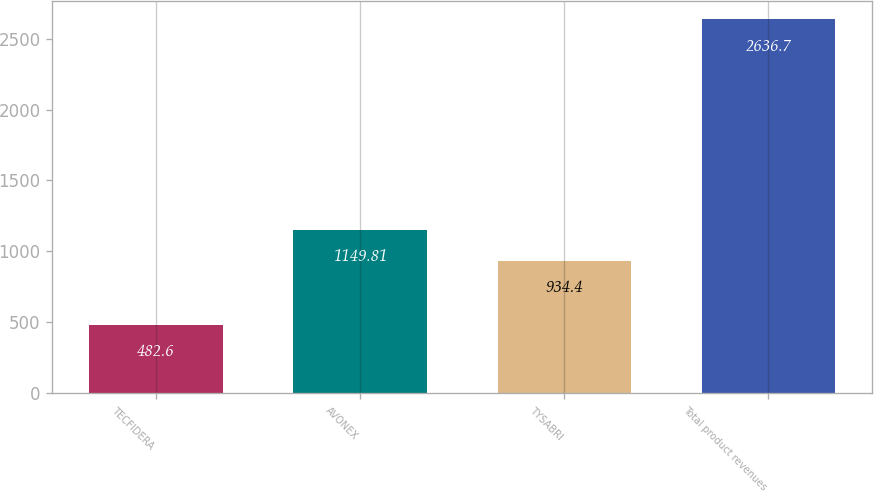Convert chart. <chart><loc_0><loc_0><loc_500><loc_500><bar_chart><fcel>TECFIDERA<fcel>AVONEX<fcel>TYSABRI<fcel>Total product revenues<nl><fcel>482.6<fcel>1149.81<fcel>934.4<fcel>2636.7<nl></chart> 